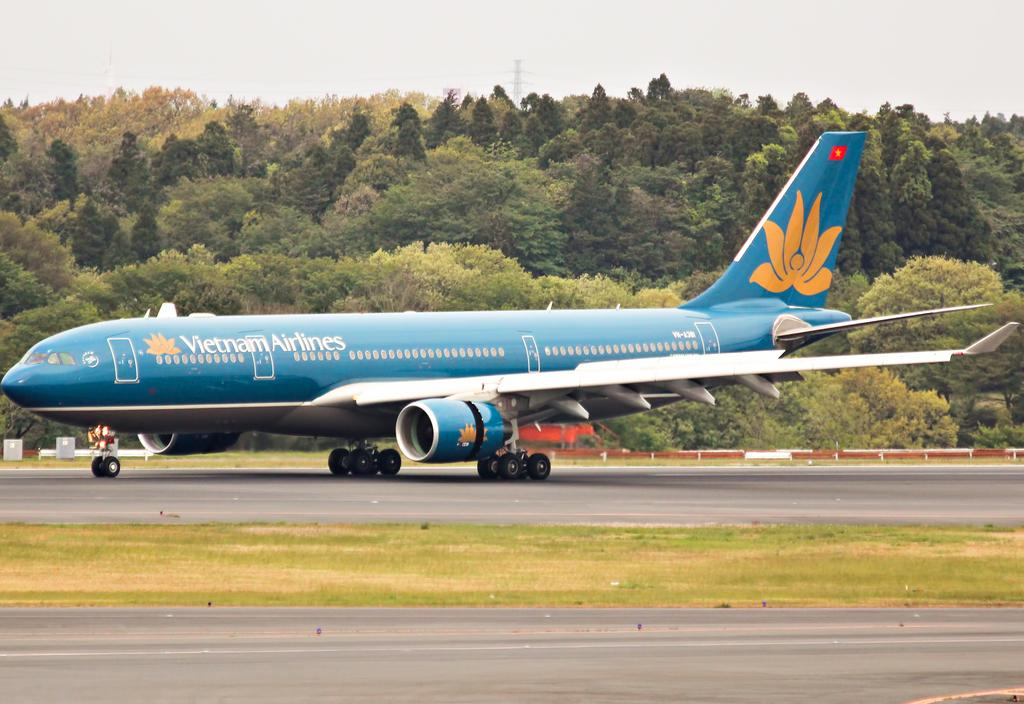<image>
Write a terse but informative summary of the picture. Airplane for Vietnam Airlines parked on a runway. 